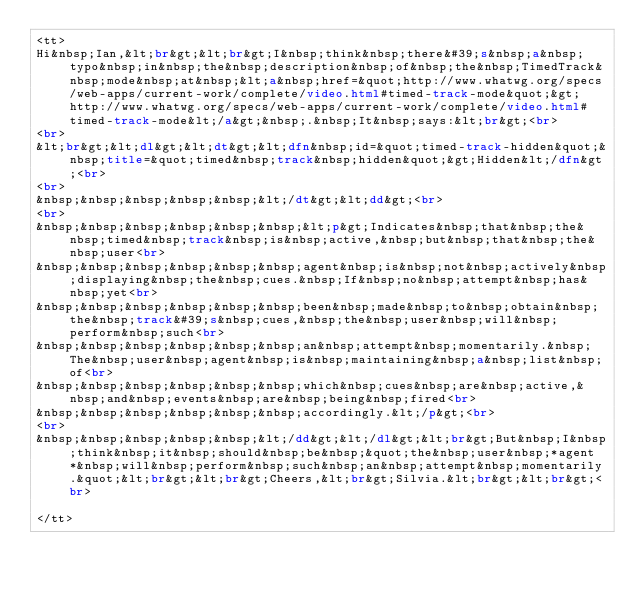<code> <loc_0><loc_0><loc_500><loc_500><_HTML_><tt>
Hi&nbsp;Ian,&lt;br&gt;&lt;br&gt;I&nbsp;think&nbsp;there&#39;s&nbsp;a&nbsp;typo&nbsp;in&nbsp;the&nbsp;description&nbsp;of&nbsp;the&nbsp;TimedTrack&nbsp;mode&nbsp;at&nbsp;&lt;a&nbsp;href=&quot;http://www.whatwg.org/specs/web-apps/current-work/complete/video.html#timed-track-mode&quot;&gt;http://www.whatwg.org/specs/web-apps/current-work/complete/video.html#timed-track-mode&lt;/a&gt;&nbsp;.&nbsp;It&nbsp;says:&lt;br&gt;<br>
<br>
&lt;br&gt;&lt;dl&gt;&lt;dt&gt;&lt;dfn&nbsp;id=&quot;timed-track-hidden&quot;&nbsp;title=&quot;timed&nbsp;track&nbsp;hidden&quot;&gt;Hidden&lt;/dfn&gt;<br>
<br>
&nbsp;&nbsp;&nbsp;&nbsp;&nbsp;&lt;/dt&gt;&lt;dd&gt;<br>
<br>
&nbsp;&nbsp;&nbsp;&nbsp;&nbsp;&nbsp;&lt;p&gt;Indicates&nbsp;that&nbsp;the&nbsp;timed&nbsp;track&nbsp;is&nbsp;active,&nbsp;but&nbsp;that&nbsp;the&nbsp;user<br>
&nbsp;&nbsp;&nbsp;&nbsp;&nbsp;&nbsp;agent&nbsp;is&nbsp;not&nbsp;actively&nbsp;displaying&nbsp;the&nbsp;cues.&nbsp;If&nbsp;no&nbsp;attempt&nbsp;has&nbsp;yet<br>
&nbsp;&nbsp;&nbsp;&nbsp;&nbsp;&nbsp;been&nbsp;made&nbsp;to&nbsp;obtain&nbsp;the&nbsp;track&#39;s&nbsp;cues,&nbsp;the&nbsp;user&nbsp;will&nbsp;perform&nbsp;such<br>
&nbsp;&nbsp;&nbsp;&nbsp;&nbsp;&nbsp;an&nbsp;attempt&nbsp;momentarily.&nbsp;The&nbsp;user&nbsp;agent&nbsp;is&nbsp;maintaining&nbsp;a&nbsp;list&nbsp;of<br>
&nbsp;&nbsp;&nbsp;&nbsp;&nbsp;&nbsp;which&nbsp;cues&nbsp;are&nbsp;active,&nbsp;and&nbsp;events&nbsp;are&nbsp;being&nbsp;fired<br>
&nbsp;&nbsp;&nbsp;&nbsp;&nbsp;&nbsp;accordingly.&lt;/p&gt;<br>
<br>
&nbsp;&nbsp;&nbsp;&nbsp;&nbsp;&lt;/dd&gt;&lt;/dl&gt;&lt;br&gt;But&nbsp;I&nbsp;think&nbsp;it&nbsp;should&nbsp;be&nbsp;&quot;the&nbsp;user&nbsp;*agent*&nbsp;will&nbsp;perform&nbsp;such&nbsp;an&nbsp;attempt&nbsp;momentarily.&quot;&lt;br&gt;&lt;br&gt;Cheers,&lt;br&gt;Silvia.&lt;br&gt;&lt;br&gt;<br>

</tt>
</code> 